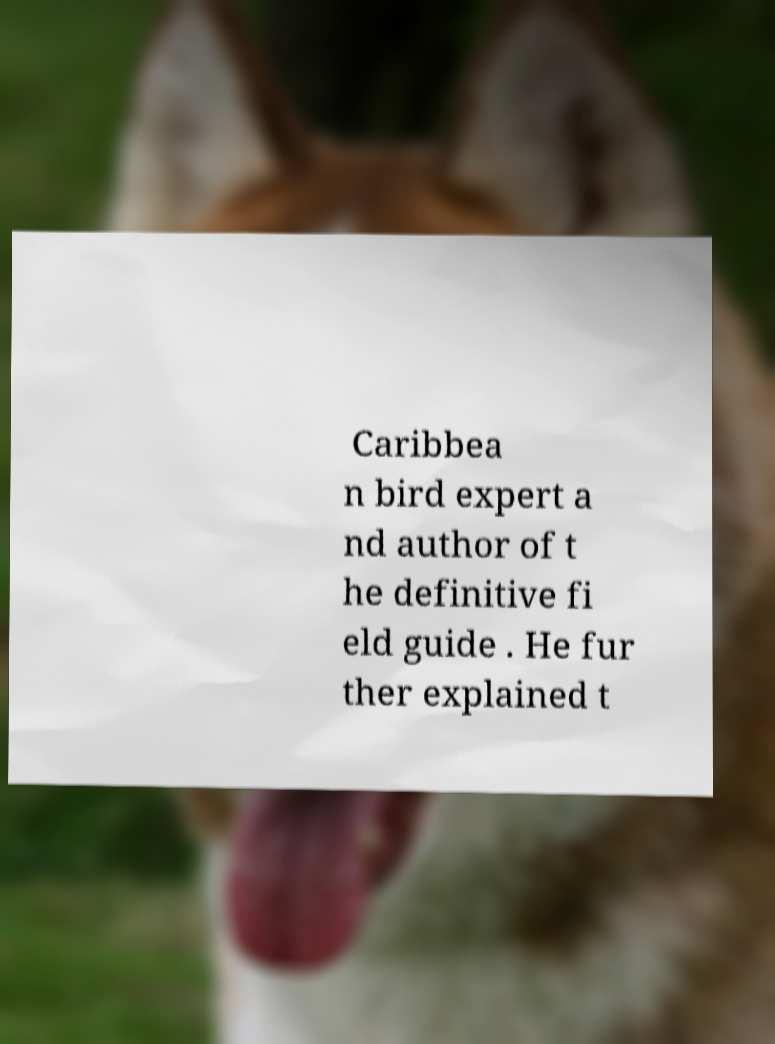There's text embedded in this image that I need extracted. Can you transcribe it verbatim? Caribbea n bird expert a nd author of t he definitive fi eld guide . He fur ther explained t 